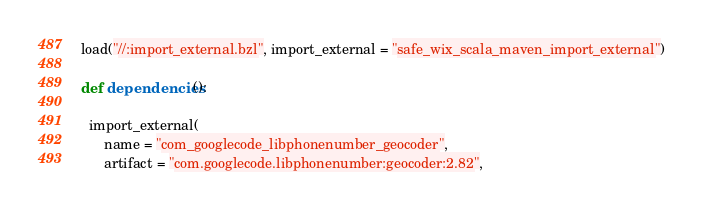Convert code to text. <code><loc_0><loc_0><loc_500><loc_500><_Python_>load("//:import_external.bzl", import_external = "safe_wix_scala_maven_import_external")

def dependencies():

  import_external(
      name = "com_googlecode_libphonenumber_geocoder",
      artifact = "com.googlecode.libphonenumber:geocoder:2.82",</code> 